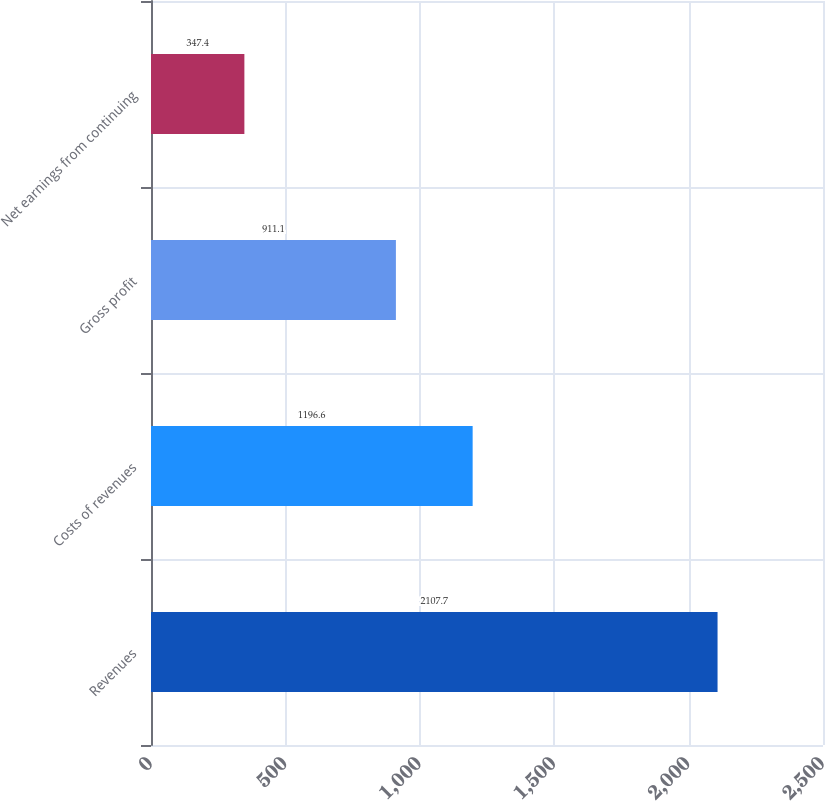Convert chart to OTSL. <chart><loc_0><loc_0><loc_500><loc_500><bar_chart><fcel>Revenues<fcel>Costs of revenues<fcel>Gross profit<fcel>Net earnings from continuing<nl><fcel>2107.7<fcel>1196.6<fcel>911.1<fcel>347.4<nl></chart> 